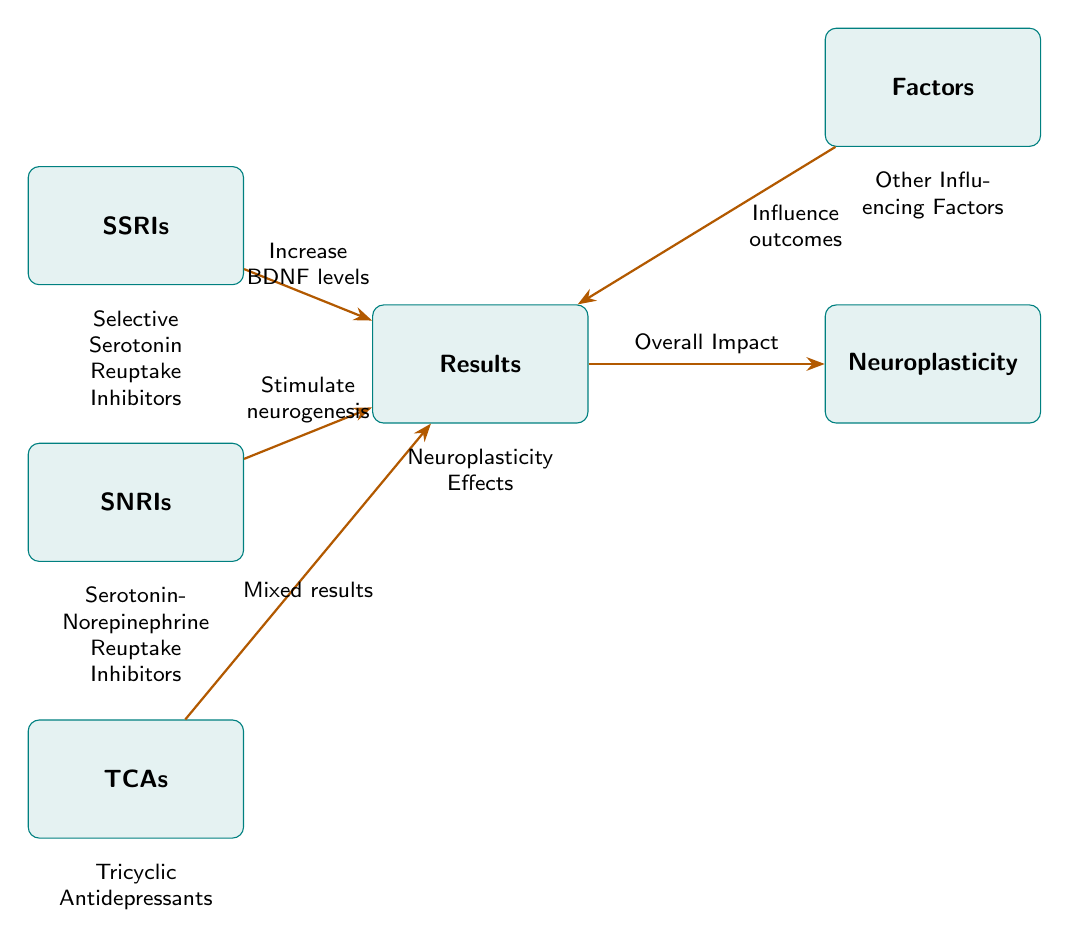What are the three classes of antidepressants represented in the diagram? The diagram clearly lists three boxes that represent different classes of antidepressants: SSRIs, SNRIs, and TCAs. These classes are explicitly labeled.
Answer: SSRIs, SNRIs, TCAs What is the relationship between SSRIs and Results? According to the diagram, there is a directed arrow from the SSRIs box to the Results box with the label "Increase BDNF levels", indicating a positive impact on the results.
Answer: Increase BDNF levels What impact do SNRIs have as shown in the diagram? The arrow from the SNRIs box to the Results box is labeled "Stimulate neurogenesis", denoting the effect that SNRIs have in the context of the diagram.
Answer: Stimulate neurogenesis How do TCAs influence the Results according to the diagram? The diagram shows an arrow from the TCAs box to the Results box labeled "Mixed results", indicating that the impact of TCAs on the results is not consistent.
Answer: Mixed results What overall impact do the Results have on Neuroplasticity? The diagram has an arrow leading from the Results box to the Neuroplasticity box, indicating that the overall impact derived from the results affects neuroplasticity.
Answer: Overall Impact Which factors influence the outcomes according to the diagram? The diagram specifies a box labeled "Factors" that connects to the Results, indicating that there are other influencing factors that affect the outcomes.
Answer: Influence outcomes What type of antidepressants is referred to as SSRIs? As per the diagram, SSRIs are defined below the box as Selective Serotonin Reuptake Inhibitors. This is additional contextual information provided in the visual.
Answer: Selective Serotonin Reuptake Inhibitors What is the direction of the influence from Factors to Results? The diagram features a directed arrow going from the Factors box to the Results box, indicating a clear influence of factors on the results.
Answer: Rightward What does Neuroplasticity depend upon according to the diagram? The diagram indicates that Neuroplasticity is influenced by the overall impact derived from the Results, as shown by the directional arrow.
Answer: Results 